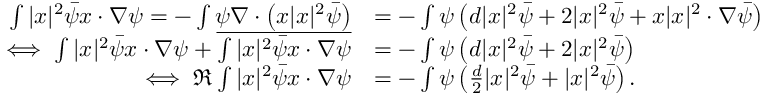Convert formula to latex. <formula><loc_0><loc_0><loc_500><loc_500>\begin{array} { r l } { \int | x | ^ { 2 } \bar { \psi } x \cdot \nabla \psi = - \int \psi \nabla \cdot \left ( x | x | ^ { 2 } \bar { \psi } \right ) } & { = - \int \psi \left ( d | x | ^ { 2 } \bar { \psi } + 2 | x | ^ { 2 } \bar { \psi } + x | x | ^ { 2 } \cdot \nabla \bar { \psi } \right ) } \\ { \iff \int | x | ^ { 2 } \bar { \psi } x \cdot \nabla \psi + \overline { { \int | x | ^ { 2 } \bar { \psi } x \cdot \nabla \psi } } } & { = - \int \psi \left ( d | x | ^ { 2 } \bar { \psi } + 2 | x | ^ { 2 } \bar { \psi } \right ) } \\ { \iff \Re \int | x | ^ { 2 } \bar { \psi } x \cdot \nabla \psi } & { = - \int \psi \left ( \frac { d } { 2 } | x | ^ { 2 } \bar { \psi } + | x | ^ { 2 } \bar { \psi } \right ) . } \end{array}</formula> 